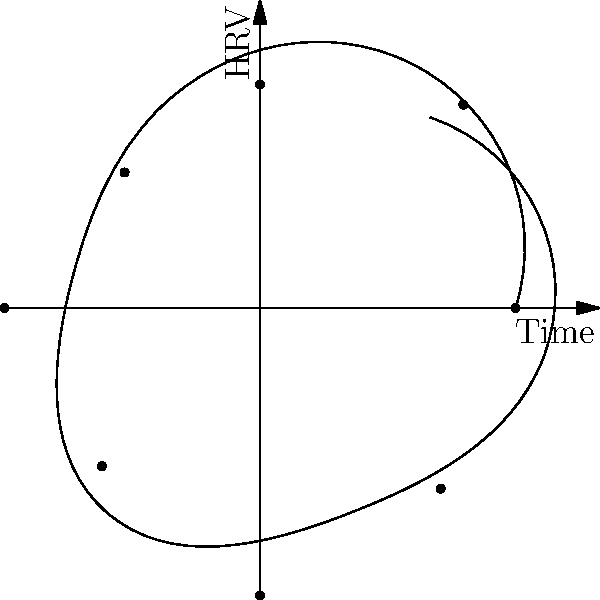In the polar plot representing heart rate variability (HRV) patterns over time, which quadrant shows the lowest HRV value, potentially indicating a period of increased stress or reduced parasympathetic activity? To answer this question, we need to analyze the polar plot step-by-step:

1. The polar plot is divided into four quadrants, each representing 90 degrees.
2. Quadrant I: 0° to 90° (top right)
3. Quadrant II: 90° to 180° (top left)
4. Quadrant III: 180° to 270° (bottom left)
5. Quadrant IV: 270° to 360° (bottom right)

6. The distance from the center represents the magnitude of HRV.
7. A shorter distance indicates lower HRV, while a longer distance indicates higher HRV.

8. Examining each quadrant:
   - Quadrant I: Values appear moderate to high
   - Quadrant II: Contains the shortest radius, indicating the lowest HRV
   - Quadrant III: Values appear moderate
   - Quadrant IV: Values appear moderate to high

9. The lowest HRV value is in Quadrant II, specifically around 135° (between 90° and 180°).

10. Lower HRV is often associated with increased stress or reduced parasympathetic activity in medical literature.

Therefore, Quadrant II shows the lowest HRV value, potentially indicating a period of increased stress or reduced parasympathetic activity.
Answer: Quadrant II 